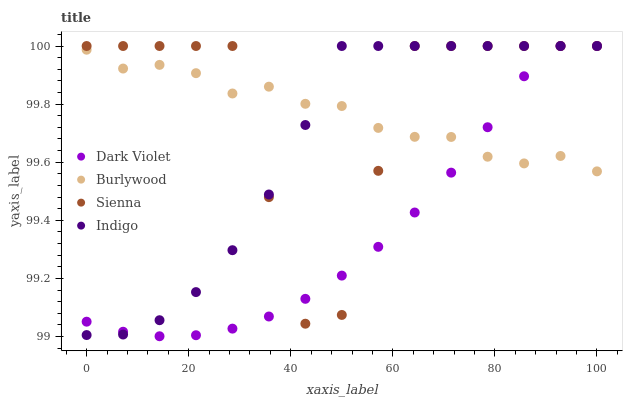Does Dark Violet have the minimum area under the curve?
Answer yes or no. Yes. Does Sienna have the maximum area under the curve?
Answer yes or no. Yes. Does Indigo have the minimum area under the curve?
Answer yes or no. No. Does Indigo have the maximum area under the curve?
Answer yes or no. No. Is Dark Violet the smoothest?
Answer yes or no. Yes. Is Sienna the roughest?
Answer yes or no. Yes. Is Indigo the smoothest?
Answer yes or no. No. Is Indigo the roughest?
Answer yes or no. No. Does Dark Violet have the lowest value?
Answer yes or no. Yes. Does Sienna have the lowest value?
Answer yes or no. No. Does Dark Violet have the highest value?
Answer yes or no. Yes. Does Indigo intersect Dark Violet?
Answer yes or no. Yes. Is Indigo less than Dark Violet?
Answer yes or no. No. Is Indigo greater than Dark Violet?
Answer yes or no. No. 